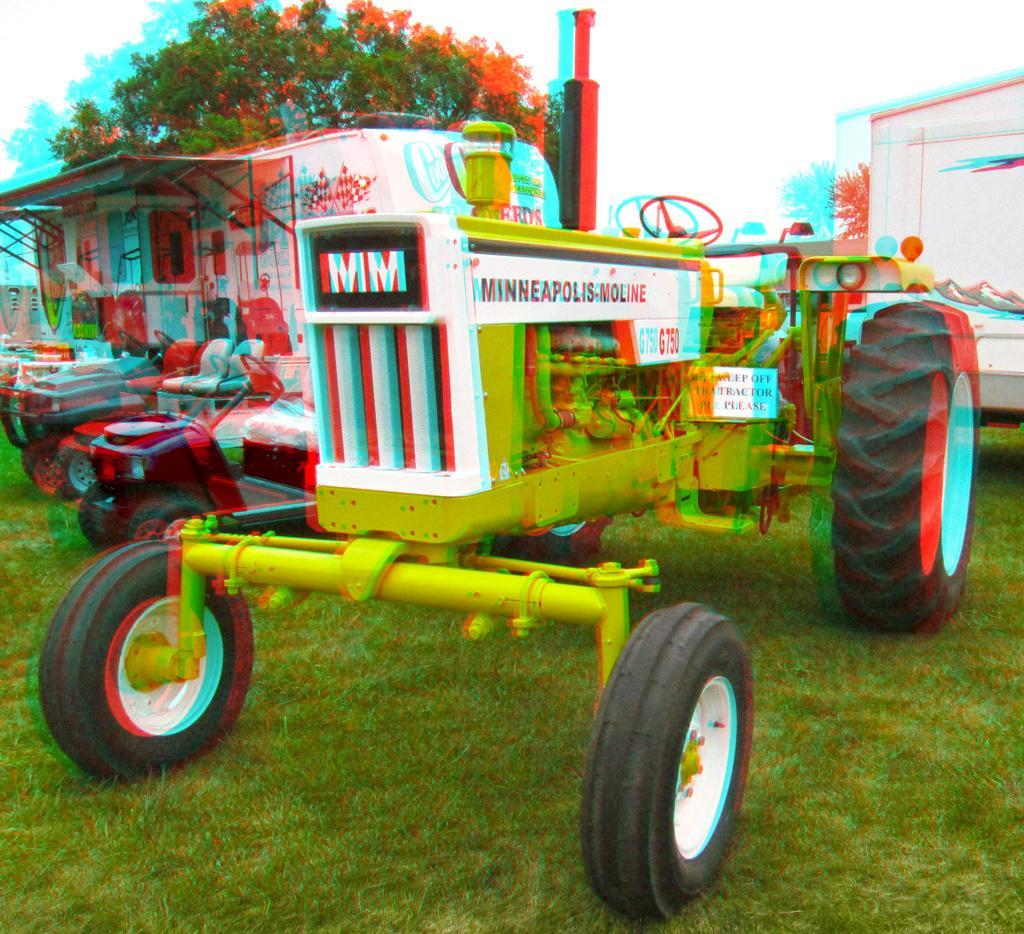In one or two sentences, can you explain what this image depicts? In this image there is a tractor in the middle. Beside the tractor there is a caravan. In the background there is a tree with the flowers. At the bottom there is grass. On the right side there is a white color container. 